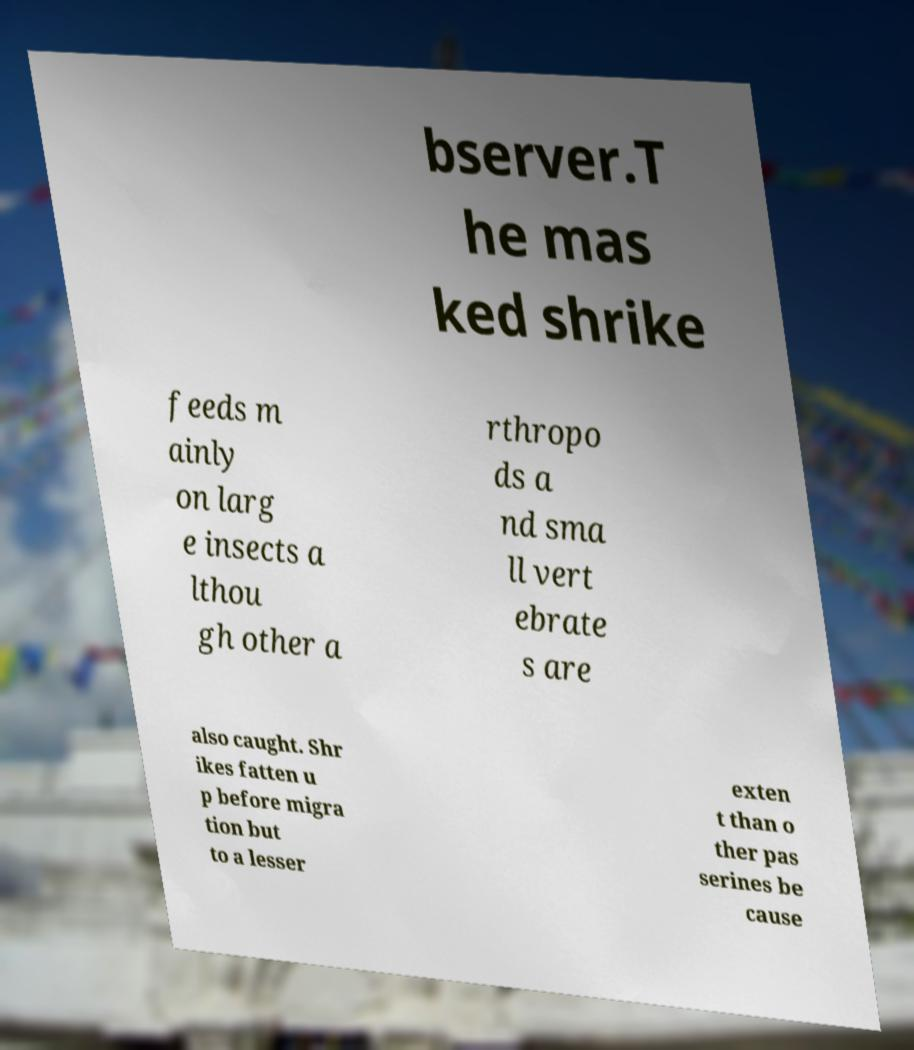Could you extract and type out the text from this image? bserver.T he mas ked shrike feeds m ainly on larg e insects a lthou gh other a rthropo ds a nd sma ll vert ebrate s are also caught. Shr ikes fatten u p before migra tion but to a lesser exten t than o ther pas serines be cause 